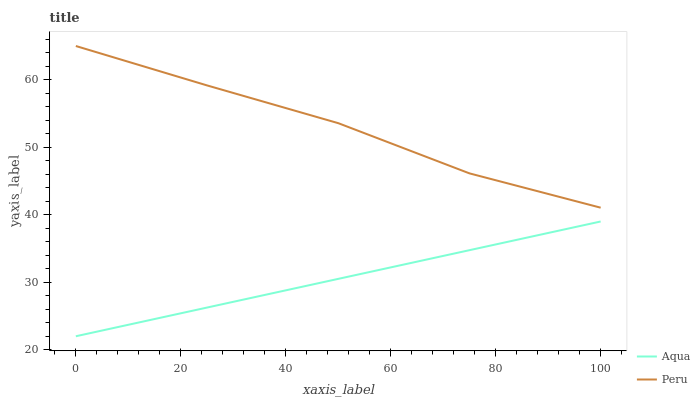Does Aqua have the minimum area under the curve?
Answer yes or no. Yes. Does Peru have the maximum area under the curve?
Answer yes or no. Yes. Does Peru have the minimum area under the curve?
Answer yes or no. No. Is Aqua the smoothest?
Answer yes or no. Yes. Is Peru the roughest?
Answer yes or no. Yes. Is Peru the smoothest?
Answer yes or no. No. Does Aqua have the lowest value?
Answer yes or no. Yes. Does Peru have the lowest value?
Answer yes or no. No. Does Peru have the highest value?
Answer yes or no. Yes. Is Aqua less than Peru?
Answer yes or no. Yes. Is Peru greater than Aqua?
Answer yes or no. Yes. Does Aqua intersect Peru?
Answer yes or no. No. 